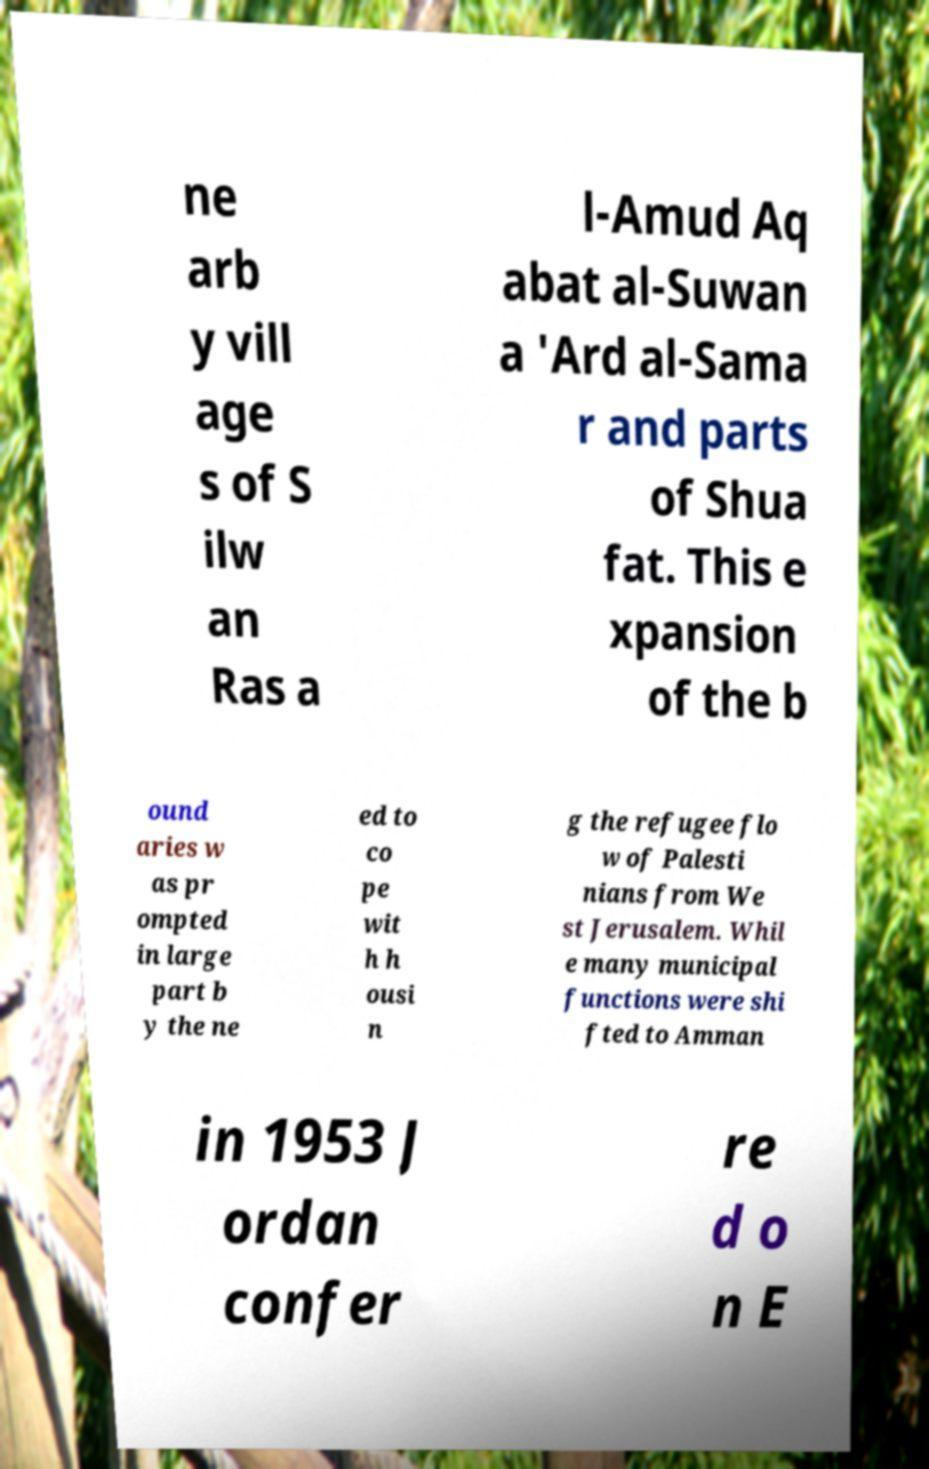Can you read and provide the text displayed in the image?This photo seems to have some interesting text. Can you extract and type it out for me? ne arb y vill age s of S ilw an Ras a l-Amud Aq abat al-Suwan a 'Ard al-Sama r and parts of Shua fat. This e xpansion of the b ound aries w as pr ompted in large part b y the ne ed to co pe wit h h ousi n g the refugee flo w of Palesti nians from We st Jerusalem. Whil e many municipal functions were shi fted to Amman in 1953 J ordan confer re d o n E 